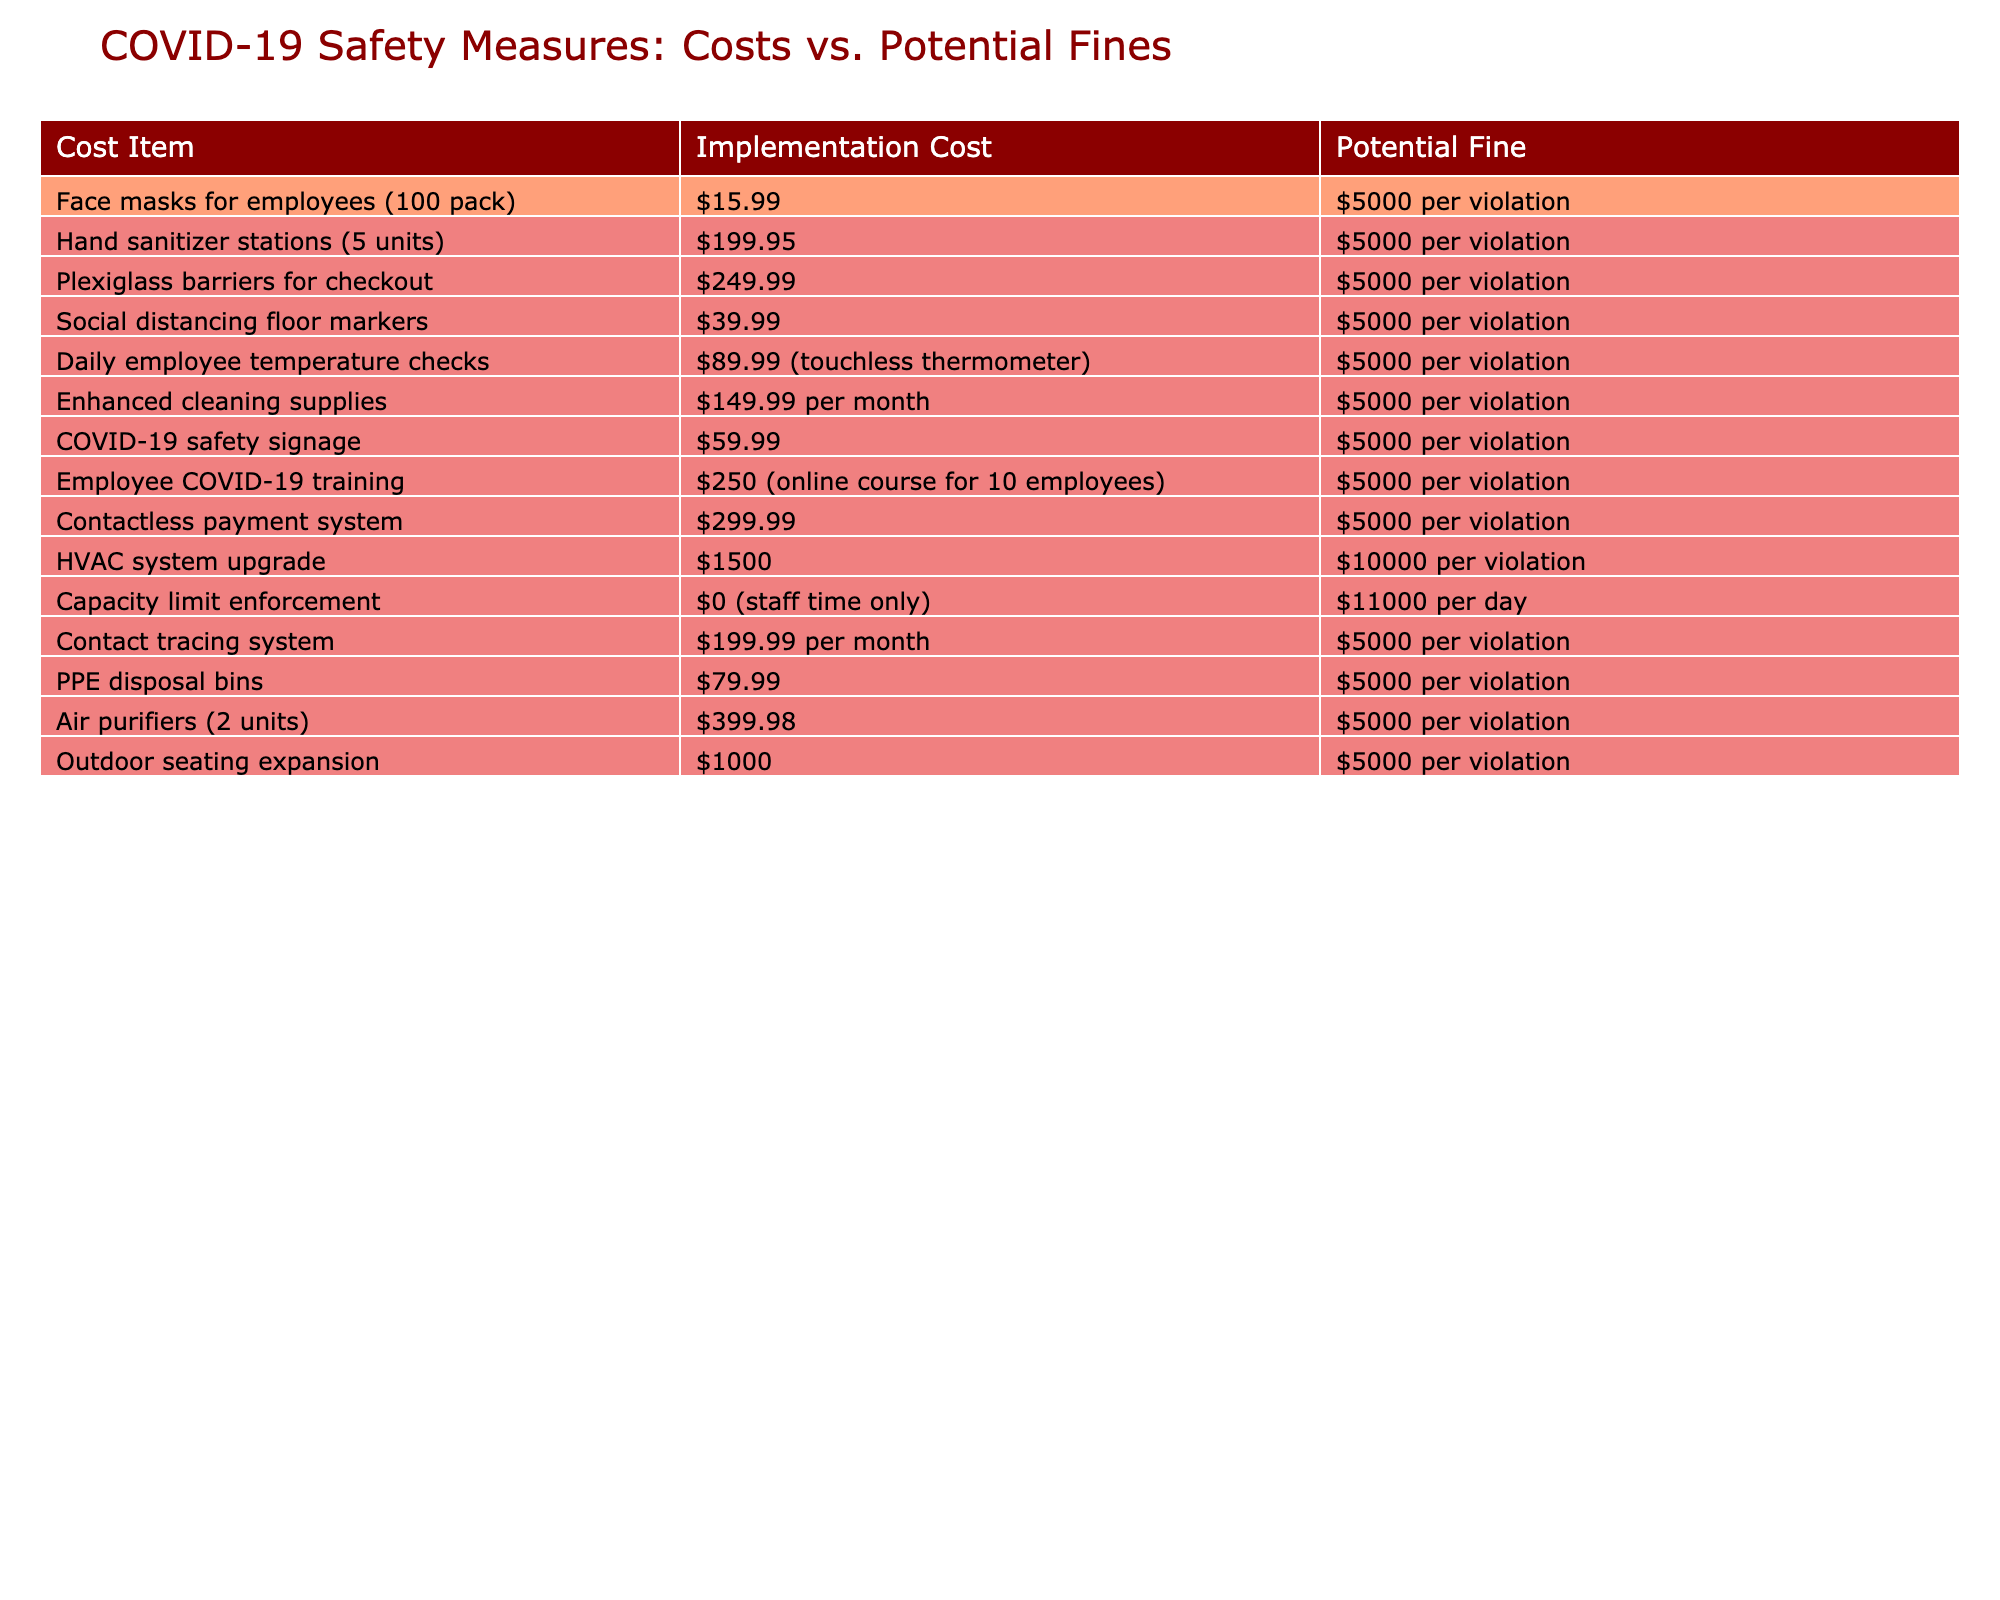What is the implementation cost for face masks for employees? The table lists the implementation cost for face masks for employees as $15.99.
Answer: $15.99 What is the potential fine for not providing hand sanitizer stations? The table indicates that the potential fine for not providing hand sanitizer stations is $5000 per violation.
Answer: $5000 per violation What is the combined total of the implementation costs for social distancing floor markers and COVID-19 safety signage? The implementation cost for social distancing floor markers is $39.99 and for COVID-19 safety signage is $59.99. Adding these together gives $39.99 + $59.99 = $99.98.
Answer: $99.98 Is the potential fine for not using an HVAC system higher than $5000? The table shows that the potential fine for not using an HVAC system is $10000 per violation, which is greater than $5000.
Answer: Yes What is the range of implementation costs for the safety measures listed in the table? The lowest implementation cost is $0 (capacity limit enforcement) and the highest is $1500 (HVAC system upgrade). So, the range is $1500 - $0 = $1500.
Answer: $1500 If a business opts for both employee COVID-19 training and PPE disposal bins, what would be the total implementation cost? The cost for employee COVID-19 training is $250 and for PPE disposal bins is $79.99. Adding these gives $250 + $79.99 = $329.99.
Answer: $329.99 Is contact tracing system included in the list of recommended COVID-19 safety measures? Yes, the table lists the contact tracing system with an implementation cost of $199.99 per month.
Answer: Yes How much more costly is the HVAC system upgrade compared to the combined cost of outdoor seating expansion and contactless payment system? The HVAC system upgrade costs $1500. The combined cost for outdoor seating expansion ($1000) and contactless payment system ($299.99) is $1000 + $299.99 = $1299.99. The difference is $1500 - $1299.99 = $200.01.
Answer: $200.01 What will be the total potential fines if a business violates the capacity limit enforcement for two consecutive days? The potential fine for capacity limit enforcement is $11000 per day. For two days, the total fine would be $11000 * 2 = $22000.
Answer: $22000 